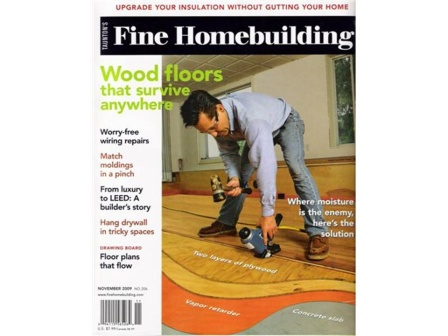Describe a possible scenario depicted inside this magazine that involves 'Wood floors that survive anywhere.' Imagine a scenario where a homeowner lives in a region with fluctuating weather conditions, exposing their wooden floors to varying levels of humidity and temperature. Inside this magazine, there could be a detailed guide on selecting the right type of wood that can withstand these conditions, along with tips on installation techniques and finishings that enhance durability. The article might also include advice on regular maintenance practices to prevent warping, cracking, or other damages, ensuring the floors remain beautiful and resilient over time. If we consider a future where homes adapt to their environments, how might this magazine envision 'Wood floors that survive anywhere'? In a futuristic scenario, the magazine might envision 'Wood floors that survive anywhere' by integrating advanced materials and smart technologies. These next-generation floors could be made from engineered wood and polymers designed to automatically adjust their properties in response to environmental changes. Embedded sensors could monitor moisture levels and temperature, triggering climate control systems within the floor to maintain optimal conditions. Additionally, nanotechnology could be employed for self-healing surfaces that repair minor scratches and dents, maintaining the floor's appearance and functionality with minimal human intervention. Such a vision highlights a blend of tradition and cutting-edge innovation, catering to the evolving needs of future homes. 